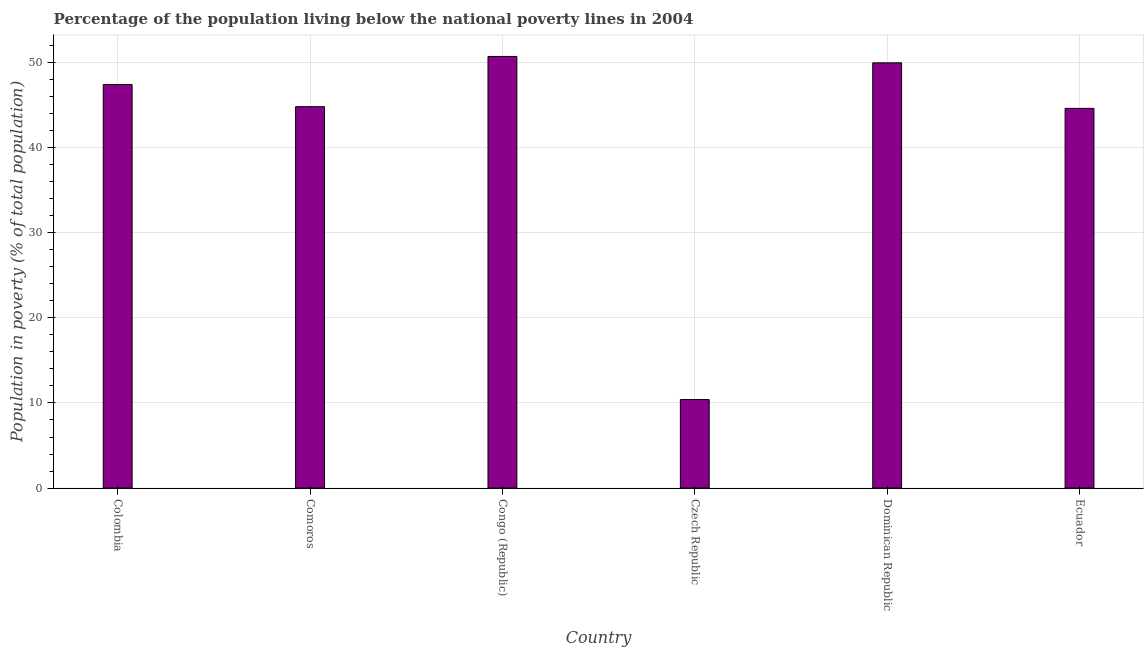Does the graph contain any zero values?
Keep it short and to the point. No. What is the title of the graph?
Make the answer very short. Percentage of the population living below the national poverty lines in 2004. What is the label or title of the X-axis?
Provide a succinct answer. Country. What is the label or title of the Y-axis?
Provide a short and direct response. Population in poverty (% of total population). What is the percentage of population living below poverty line in Ecuador?
Your response must be concise. 44.6. Across all countries, what is the maximum percentage of population living below poverty line?
Your response must be concise. 50.7. In which country was the percentage of population living below poverty line maximum?
Your answer should be very brief. Congo (Republic). In which country was the percentage of population living below poverty line minimum?
Your answer should be very brief. Czech Republic. What is the sum of the percentage of population living below poverty line?
Provide a succinct answer. 247.85. What is the average percentage of population living below poverty line per country?
Make the answer very short. 41.31. What is the median percentage of population living below poverty line?
Offer a terse response. 46.1. What is the ratio of the percentage of population living below poverty line in Comoros to that in Ecuador?
Ensure brevity in your answer.  1. Is the percentage of population living below poverty line in Czech Republic less than that in Ecuador?
Give a very brief answer. Yes. What is the difference between the highest and the second highest percentage of population living below poverty line?
Offer a terse response. 0.75. Is the sum of the percentage of population living below poverty line in Colombia and Ecuador greater than the maximum percentage of population living below poverty line across all countries?
Provide a succinct answer. Yes. What is the difference between the highest and the lowest percentage of population living below poverty line?
Make the answer very short. 40.3. How many bars are there?
Offer a very short reply. 6. How many countries are there in the graph?
Give a very brief answer. 6. What is the difference between two consecutive major ticks on the Y-axis?
Your response must be concise. 10. What is the Population in poverty (% of total population) of Colombia?
Your answer should be compact. 47.4. What is the Population in poverty (% of total population) of Comoros?
Offer a very short reply. 44.8. What is the Population in poverty (% of total population) of Congo (Republic)?
Keep it short and to the point. 50.7. What is the Population in poverty (% of total population) in Dominican Republic?
Your answer should be very brief. 49.95. What is the Population in poverty (% of total population) in Ecuador?
Offer a terse response. 44.6. What is the difference between the Population in poverty (% of total population) in Colombia and Comoros?
Keep it short and to the point. 2.6. What is the difference between the Population in poverty (% of total population) in Colombia and Congo (Republic)?
Make the answer very short. -3.3. What is the difference between the Population in poverty (% of total population) in Colombia and Dominican Republic?
Offer a very short reply. -2.55. What is the difference between the Population in poverty (% of total population) in Comoros and Czech Republic?
Make the answer very short. 34.4. What is the difference between the Population in poverty (% of total population) in Comoros and Dominican Republic?
Your response must be concise. -5.15. What is the difference between the Population in poverty (% of total population) in Comoros and Ecuador?
Your response must be concise. 0.2. What is the difference between the Population in poverty (% of total population) in Congo (Republic) and Czech Republic?
Offer a terse response. 40.3. What is the difference between the Population in poverty (% of total population) in Congo (Republic) and Ecuador?
Give a very brief answer. 6.1. What is the difference between the Population in poverty (% of total population) in Czech Republic and Dominican Republic?
Provide a succinct answer. -39.55. What is the difference between the Population in poverty (% of total population) in Czech Republic and Ecuador?
Make the answer very short. -34.2. What is the difference between the Population in poverty (% of total population) in Dominican Republic and Ecuador?
Provide a succinct answer. 5.35. What is the ratio of the Population in poverty (% of total population) in Colombia to that in Comoros?
Keep it short and to the point. 1.06. What is the ratio of the Population in poverty (% of total population) in Colombia to that in Congo (Republic)?
Offer a terse response. 0.94. What is the ratio of the Population in poverty (% of total population) in Colombia to that in Czech Republic?
Your answer should be compact. 4.56. What is the ratio of the Population in poverty (% of total population) in Colombia to that in Dominican Republic?
Provide a short and direct response. 0.95. What is the ratio of the Population in poverty (% of total population) in Colombia to that in Ecuador?
Keep it short and to the point. 1.06. What is the ratio of the Population in poverty (% of total population) in Comoros to that in Congo (Republic)?
Make the answer very short. 0.88. What is the ratio of the Population in poverty (% of total population) in Comoros to that in Czech Republic?
Your answer should be compact. 4.31. What is the ratio of the Population in poverty (% of total population) in Comoros to that in Dominican Republic?
Your answer should be very brief. 0.9. What is the ratio of the Population in poverty (% of total population) in Congo (Republic) to that in Czech Republic?
Give a very brief answer. 4.88. What is the ratio of the Population in poverty (% of total population) in Congo (Republic) to that in Dominican Republic?
Your answer should be compact. 1.01. What is the ratio of the Population in poverty (% of total population) in Congo (Republic) to that in Ecuador?
Make the answer very short. 1.14. What is the ratio of the Population in poverty (% of total population) in Czech Republic to that in Dominican Republic?
Keep it short and to the point. 0.21. What is the ratio of the Population in poverty (% of total population) in Czech Republic to that in Ecuador?
Ensure brevity in your answer.  0.23. What is the ratio of the Population in poverty (% of total population) in Dominican Republic to that in Ecuador?
Offer a terse response. 1.12. 